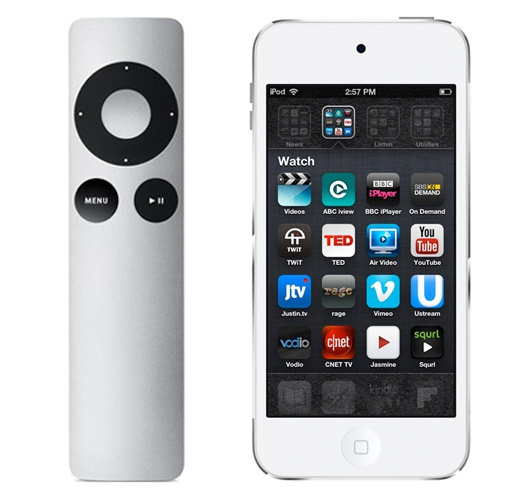Describe the objects in this image and their specific colors. I can see cell phone in white, black, and gray tones and remote in white, lightgray, darkgray, and black tones in this image. 